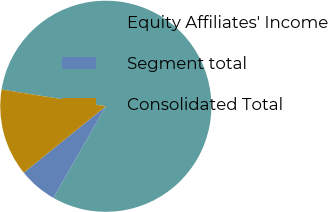<chart> <loc_0><loc_0><loc_500><loc_500><pie_chart><fcel>Equity Affiliates' Income<fcel>Segment total<fcel>Consolidated Total<nl><fcel>80.74%<fcel>5.89%<fcel>13.37%<nl></chart> 